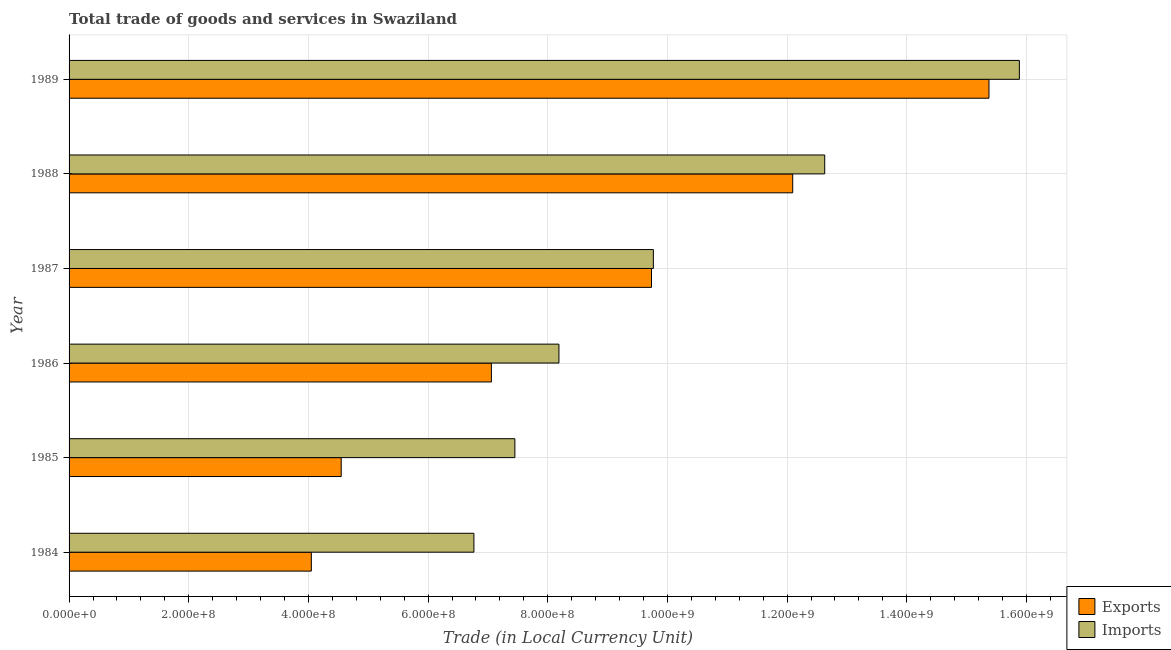How many different coloured bars are there?
Offer a terse response. 2. How many groups of bars are there?
Your answer should be very brief. 6. Are the number of bars per tick equal to the number of legend labels?
Your response must be concise. Yes. Are the number of bars on each tick of the Y-axis equal?
Ensure brevity in your answer.  Yes. What is the label of the 3rd group of bars from the top?
Your answer should be compact. 1987. What is the export of goods and services in 1984?
Provide a succinct answer. 4.05e+08. Across all years, what is the maximum export of goods and services?
Provide a succinct answer. 1.54e+09. Across all years, what is the minimum export of goods and services?
Keep it short and to the point. 4.05e+08. In which year was the imports of goods and services minimum?
Provide a succinct answer. 1984. What is the total export of goods and services in the graph?
Keep it short and to the point. 5.29e+09. What is the difference between the export of goods and services in 1987 and that in 1989?
Offer a very short reply. -5.64e+08. What is the difference between the export of goods and services in 1987 and the imports of goods and services in 1985?
Ensure brevity in your answer.  2.28e+08. What is the average imports of goods and services per year?
Offer a terse response. 1.01e+09. In the year 1988, what is the difference between the export of goods and services and imports of goods and services?
Provide a succinct answer. -5.35e+07. In how many years, is the imports of goods and services greater than 1200000000 LCU?
Your response must be concise. 2. What is the ratio of the export of goods and services in 1984 to that in 1988?
Make the answer very short. 0.34. Is the export of goods and services in 1984 less than that in 1986?
Your response must be concise. Yes. What is the difference between the highest and the second highest export of goods and services?
Provide a succinct answer. 3.28e+08. What is the difference between the highest and the lowest export of goods and services?
Offer a terse response. 1.13e+09. In how many years, is the export of goods and services greater than the average export of goods and services taken over all years?
Your answer should be compact. 3. Is the sum of the imports of goods and services in 1986 and 1987 greater than the maximum export of goods and services across all years?
Offer a very short reply. Yes. What does the 1st bar from the top in 1988 represents?
Offer a very short reply. Imports. What does the 1st bar from the bottom in 1986 represents?
Offer a terse response. Exports. Are the values on the major ticks of X-axis written in scientific E-notation?
Give a very brief answer. Yes. Where does the legend appear in the graph?
Offer a terse response. Bottom right. What is the title of the graph?
Provide a succinct answer. Total trade of goods and services in Swaziland. Does "Arms imports" appear as one of the legend labels in the graph?
Your answer should be very brief. No. What is the label or title of the X-axis?
Your answer should be compact. Trade (in Local Currency Unit). What is the label or title of the Y-axis?
Make the answer very short. Year. What is the Trade (in Local Currency Unit) of Exports in 1984?
Give a very brief answer. 4.05e+08. What is the Trade (in Local Currency Unit) in Imports in 1984?
Your answer should be compact. 6.77e+08. What is the Trade (in Local Currency Unit) of Exports in 1985?
Your answer should be compact. 4.55e+08. What is the Trade (in Local Currency Unit) of Imports in 1985?
Give a very brief answer. 7.45e+08. What is the Trade (in Local Currency Unit) in Exports in 1986?
Offer a terse response. 7.06e+08. What is the Trade (in Local Currency Unit) in Imports in 1986?
Your answer should be very brief. 8.19e+08. What is the Trade (in Local Currency Unit) in Exports in 1987?
Your response must be concise. 9.73e+08. What is the Trade (in Local Currency Unit) of Imports in 1987?
Your answer should be very brief. 9.76e+08. What is the Trade (in Local Currency Unit) of Exports in 1988?
Offer a very short reply. 1.21e+09. What is the Trade (in Local Currency Unit) of Imports in 1988?
Give a very brief answer. 1.26e+09. What is the Trade (in Local Currency Unit) in Exports in 1989?
Give a very brief answer. 1.54e+09. What is the Trade (in Local Currency Unit) in Imports in 1989?
Your answer should be compact. 1.59e+09. Across all years, what is the maximum Trade (in Local Currency Unit) of Exports?
Offer a very short reply. 1.54e+09. Across all years, what is the maximum Trade (in Local Currency Unit) in Imports?
Your answer should be very brief. 1.59e+09. Across all years, what is the minimum Trade (in Local Currency Unit) in Exports?
Your answer should be very brief. 4.05e+08. Across all years, what is the minimum Trade (in Local Currency Unit) of Imports?
Offer a terse response. 6.77e+08. What is the total Trade (in Local Currency Unit) in Exports in the graph?
Offer a very short reply. 5.29e+09. What is the total Trade (in Local Currency Unit) of Imports in the graph?
Offer a very short reply. 6.07e+09. What is the difference between the Trade (in Local Currency Unit) of Exports in 1984 and that in 1985?
Ensure brevity in your answer.  -4.99e+07. What is the difference between the Trade (in Local Currency Unit) of Imports in 1984 and that in 1985?
Offer a terse response. -6.85e+07. What is the difference between the Trade (in Local Currency Unit) of Exports in 1984 and that in 1986?
Provide a short and direct response. -3.01e+08. What is the difference between the Trade (in Local Currency Unit) of Imports in 1984 and that in 1986?
Provide a succinct answer. -1.42e+08. What is the difference between the Trade (in Local Currency Unit) in Exports in 1984 and that in 1987?
Provide a succinct answer. -5.68e+08. What is the difference between the Trade (in Local Currency Unit) of Imports in 1984 and that in 1987?
Your response must be concise. -3.00e+08. What is the difference between the Trade (in Local Currency Unit) of Exports in 1984 and that in 1988?
Your answer should be compact. -8.05e+08. What is the difference between the Trade (in Local Currency Unit) in Imports in 1984 and that in 1988?
Offer a very short reply. -5.86e+08. What is the difference between the Trade (in Local Currency Unit) of Exports in 1984 and that in 1989?
Offer a terse response. -1.13e+09. What is the difference between the Trade (in Local Currency Unit) in Imports in 1984 and that in 1989?
Offer a very short reply. -9.12e+08. What is the difference between the Trade (in Local Currency Unit) in Exports in 1985 and that in 1986?
Your answer should be compact. -2.51e+08. What is the difference between the Trade (in Local Currency Unit) in Imports in 1985 and that in 1986?
Ensure brevity in your answer.  -7.36e+07. What is the difference between the Trade (in Local Currency Unit) in Exports in 1985 and that in 1987?
Your answer should be very brief. -5.19e+08. What is the difference between the Trade (in Local Currency Unit) of Imports in 1985 and that in 1987?
Ensure brevity in your answer.  -2.31e+08. What is the difference between the Trade (in Local Currency Unit) in Exports in 1985 and that in 1988?
Offer a very short reply. -7.55e+08. What is the difference between the Trade (in Local Currency Unit) of Imports in 1985 and that in 1988?
Make the answer very short. -5.18e+08. What is the difference between the Trade (in Local Currency Unit) in Exports in 1985 and that in 1989?
Your answer should be compact. -1.08e+09. What is the difference between the Trade (in Local Currency Unit) in Imports in 1985 and that in 1989?
Provide a short and direct response. -8.43e+08. What is the difference between the Trade (in Local Currency Unit) in Exports in 1986 and that in 1987?
Make the answer very short. -2.68e+08. What is the difference between the Trade (in Local Currency Unit) of Imports in 1986 and that in 1987?
Make the answer very short. -1.58e+08. What is the difference between the Trade (in Local Currency Unit) in Exports in 1986 and that in 1988?
Make the answer very short. -5.04e+08. What is the difference between the Trade (in Local Currency Unit) in Imports in 1986 and that in 1988?
Offer a very short reply. -4.44e+08. What is the difference between the Trade (in Local Currency Unit) in Exports in 1986 and that in 1989?
Your response must be concise. -8.32e+08. What is the difference between the Trade (in Local Currency Unit) in Imports in 1986 and that in 1989?
Your response must be concise. -7.69e+08. What is the difference between the Trade (in Local Currency Unit) in Exports in 1987 and that in 1988?
Your answer should be very brief. -2.36e+08. What is the difference between the Trade (in Local Currency Unit) in Imports in 1987 and that in 1988?
Make the answer very short. -2.86e+08. What is the difference between the Trade (in Local Currency Unit) in Exports in 1987 and that in 1989?
Your response must be concise. -5.64e+08. What is the difference between the Trade (in Local Currency Unit) of Imports in 1987 and that in 1989?
Your answer should be compact. -6.12e+08. What is the difference between the Trade (in Local Currency Unit) of Exports in 1988 and that in 1989?
Your answer should be very brief. -3.28e+08. What is the difference between the Trade (in Local Currency Unit) in Imports in 1988 and that in 1989?
Your response must be concise. -3.25e+08. What is the difference between the Trade (in Local Currency Unit) in Exports in 1984 and the Trade (in Local Currency Unit) in Imports in 1985?
Provide a short and direct response. -3.40e+08. What is the difference between the Trade (in Local Currency Unit) in Exports in 1984 and the Trade (in Local Currency Unit) in Imports in 1986?
Your answer should be compact. -4.14e+08. What is the difference between the Trade (in Local Currency Unit) of Exports in 1984 and the Trade (in Local Currency Unit) of Imports in 1987?
Make the answer very short. -5.72e+08. What is the difference between the Trade (in Local Currency Unit) in Exports in 1984 and the Trade (in Local Currency Unit) in Imports in 1988?
Provide a short and direct response. -8.58e+08. What is the difference between the Trade (in Local Currency Unit) in Exports in 1984 and the Trade (in Local Currency Unit) in Imports in 1989?
Make the answer very short. -1.18e+09. What is the difference between the Trade (in Local Currency Unit) in Exports in 1985 and the Trade (in Local Currency Unit) in Imports in 1986?
Provide a short and direct response. -3.64e+08. What is the difference between the Trade (in Local Currency Unit) in Exports in 1985 and the Trade (in Local Currency Unit) in Imports in 1987?
Your response must be concise. -5.22e+08. What is the difference between the Trade (in Local Currency Unit) in Exports in 1985 and the Trade (in Local Currency Unit) in Imports in 1988?
Your response must be concise. -8.08e+08. What is the difference between the Trade (in Local Currency Unit) of Exports in 1985 and the Trade (in Local Currency Unit) of Imports in 1989?
Your response must be concise. -1.13e+09. What is the difference between the Trade (in Local Currency Unit) of Exports in 1986 and the Trade (in Local Currency Unit) of Imports in 1987?
Give a very brief answer. -2.71e+08. What is the difference between the Trade (in Local Currency Unit) in Exports in 1986 and the Trade (in Local Currency Unit) in Imports in 1988?
Offer a terse response. -5.57e+08. What is the difference between the Trade (in Local Currency Unit) in Exports in 1986 and the Trade (in Local Currency Unit) in Imports in 1989?
Your answer should be very brief. -8.82e+08. What is the difference between the Trade (in Local Currency Unit) in Exports in 1987 and the Trade (in Local Currency Unit) in Imports in 1988?
Your response must be concise. -2.90e+08. What is the difference between the Trade (in Local Currency Unit) in Exports in 1987 and the Trade (in Local Currency Unit) in Imports in 1989?
Ensure brevity in your answer.  -6.15e+08. What is the difference between the Trade (in Local Currency Unit) of Exports in 1988 and the Trade (in Local Currency Unit) of Imports in 1989?
Your response must be concise. -3.79e+08. What is the average Trade (in Local Currency Unit) in Exports per year?
Ensure brevity in your answer.  8.81e+08. What is the average Trade (in Local Currency Unit) in Imports per year?
Offer a very short reply. 1.01e+09. In the year 1984, what is the difference between the Trade (in Local Currency Unit) in Exports and Trade (in Local Currency Unit) in Imports?
Your answer should be compact. -2.72e+08. In the year 1985, what is the difference between the Trade (in Local Currency Unit) of Exports and Trade (in Local Currency Unit) of Imports?
Ensure brevity in your answer.  -2.90e+08. In the year 1986, what is the difference between the Trade (in Local Currency Unit) in Exports and Trade (in Local Currency Unit) in Imports?
Your response must be concise. -1.13e+08. In the year 1987, what is the difference between the Trade (in Local Currency Unit) in Exports and Trade (in Local Currency Unit) in Imports?
Your answer should be very brief. -3.10e+06. In the year 1988, what is the difference between the Trade (in Local Currency Unit) in Exports and Trade (in Local Currency Unit) in Imports?
Make the answer very short. -5.35e+07. In the year 1989, what is the difference between the Trade (in Local Currency Unit) in Exports and Trade (in Local Currency Unit) in Imports?
Provide a short and direct response. -5.08e+07. What is the ratio of the Trade (in Local Currency Unit) of Exports in 1984 to that in 1985?
Ensure brevity in your answer.  0.89. What is the ratio of the Trade (in Local Currency Unit) of Imports in 1984 to that in 1985?
Ensure brevity in your answer.  0.91. What is the ratio of the Trade (in Local Currency Unit) in Exports in 1984 to that in 1986?
Offer a very short reply. 0.57. What is the ratio of the Trade (in Local Currency Unit) of Imports in 1984 to that in 1986?
Make the answer very short. 0.83. What is the ratio of the Trade (in Local Currency Unit) in Exports in 1984 to that in 1987?
Keep it short and to the point. 0.42. What is the ratio of the Trade (in Local Currency Unit) in Imports in 1984 to that in 1987?
Provide a succinct answer. 0.69. What is the ratio of the Trade (in Local Currency Unit) in Exports in 1984 to that in 1988?
Ensure brevity in your answer.  0.33. What is the ratio of the Trade (in Local Currency Unit) in Imports in 1984 to that in 1988?
Ensure brevity in your answer.  0.54. What is the ratio of the Trade (in Local Currency Unit) in Exports in 1984 to that in 1989?
Provide a short and direct response. 0.26. What is the ratio of the Trade (in Local Currency Unit) in Imports in 1984 to that in 1989?
Provide a succinct answer. 0.43. What is the ratio of the Trade (in Local Currency Unit) in Exports in 1985 to that in 1986?
Give a very brief answer. 0.64. What is the ratio of the Trade (in Local Currency Unit) in Imports in 1985 to that in 1986?
Keep it short and to the point. 0.91. What is the ratio of the Trade (in Local Currency Unit) in Exports in 1985 to that in 1987?
Make the answer very short. 0.47. What is the ratio of the Trade (in Local Currency Unit) in Imports in 1985 to that in 1987?
Provide a succinct answer. 0.76. What is the ratio of the Trade (in Local Currency Unit) of Exports in 1985 to that in 1988?
Offer a terse response. 0.38. What is the ratio of the Trade (in Local Currency Unit) in Imports in 1985 to that in 1988?
Your response must be concise. 0.59. What is the ratio of the Trade (in Local Currency Unit) of Exports in 1985 to that in 1989?
Make the answer very short. 0.3. What is the ratio of the Trade (in Local Currency Unit) of Imports in 1985 to that in 1989?
Make the answer very short. 0.47. What is the ratio of the Trade (in Local Currency Unit) in Exports in 1986 to that in 1987?
Your answer should be very brief. 0.73. What is the ratio of the Trade (in Local Currency Unit) of Imports in 1986 to that in 1987?
Provide a succinct answer. 0.84. What is the ratio of the Trade (in Local Currency Unit) of Exports in 1986 to that in 1988?
Offer a terse response. 0.58. What is the ratio of the Trade (in Local Currency Unit) of Imports in 1986 to that in 1988?
Offer a terse response. 0.65. What is the ratio of the Trade (in Local Currency Unit) of Exports in 1986 to that in 1989?
Offer a terse response. 0.46. What is the ratio of the Trade (in Local Currency Unit) of Imports in 1986 to that in 1989?
Your answer should be compact. 0.52. What is the ratio of the Trade (in Local Currency Unit) in Exports in 1987 to that in 1988?
Your answer should be very brief. 0.8. What is the ratio of the Trade (in Local Currency Unit) of Imports in 1987 to that in 1988?
Your response must be concise. 0.77. What is the ratio of the Trade (in Local Currency Unit) of Exports in 1987 to that in 1989?
Your answer should be compact. 0.63. What is the ratio of the Trade (in Local Currency Unit) of Imports in 1987 to that in 1989?
Provide a succinct answer. 0.61. What is the ratio of the Trade (in Local Currency Unit) in Exports in 1988 to that in 1989?
Your answer should be compact. 0.79. What is the ratio of the Trade (in Local Currency Unit) in Imports in 1988 to that in 1989?
Make the answer very short. 0.8. What is the difference between the highest and the second highest Trade (in Local Currency Unit) in Exports?
Give a very brief answer. 3.28e+08. What is the difference between the highest and the second highest Trade (in Local Currency Unit) of Imports?
Keep it short and to the point. 3.25e+08. What is the difference between the highest and the lowest Trade (in Local Currency Unit) of Exports?
Provide a short and direct response. 1.13e+09. What is the difference between the highest and the lowest Trade (in Local Currency Unit) of Imports?
Your response must be concise. 9.12e+08. 